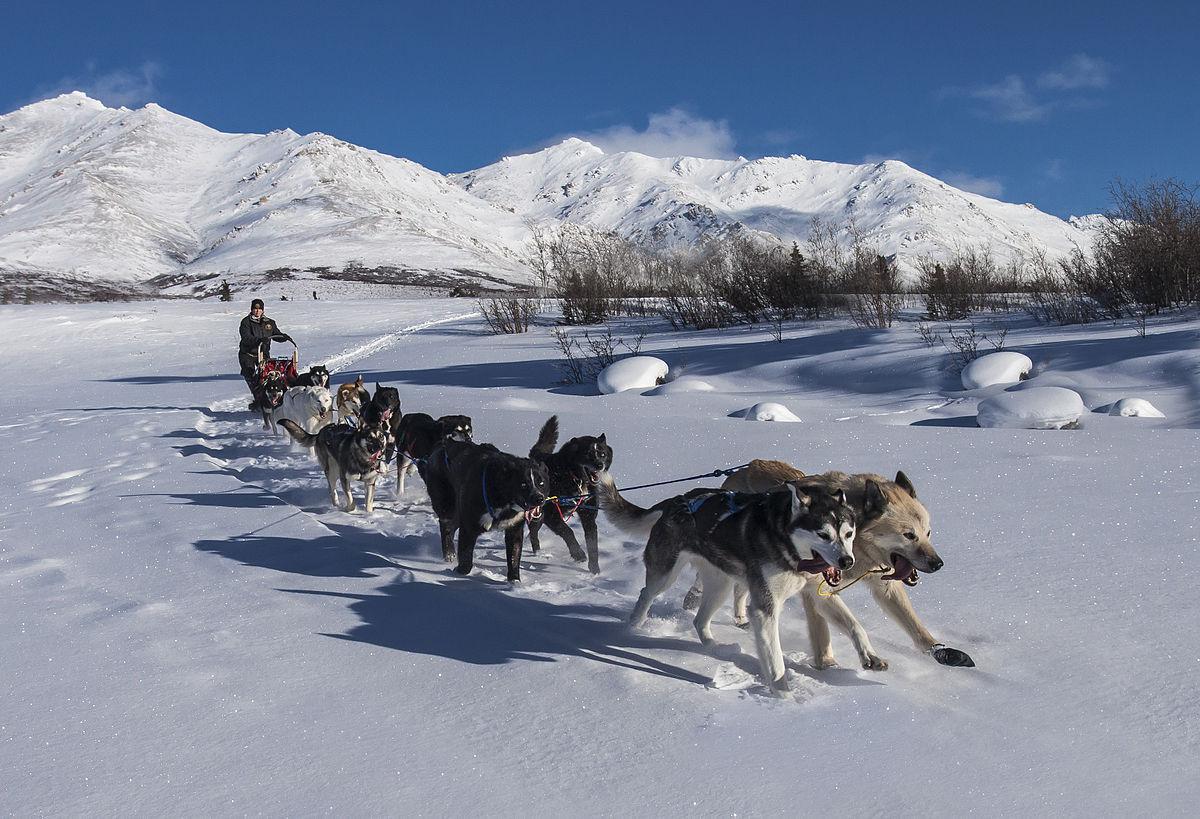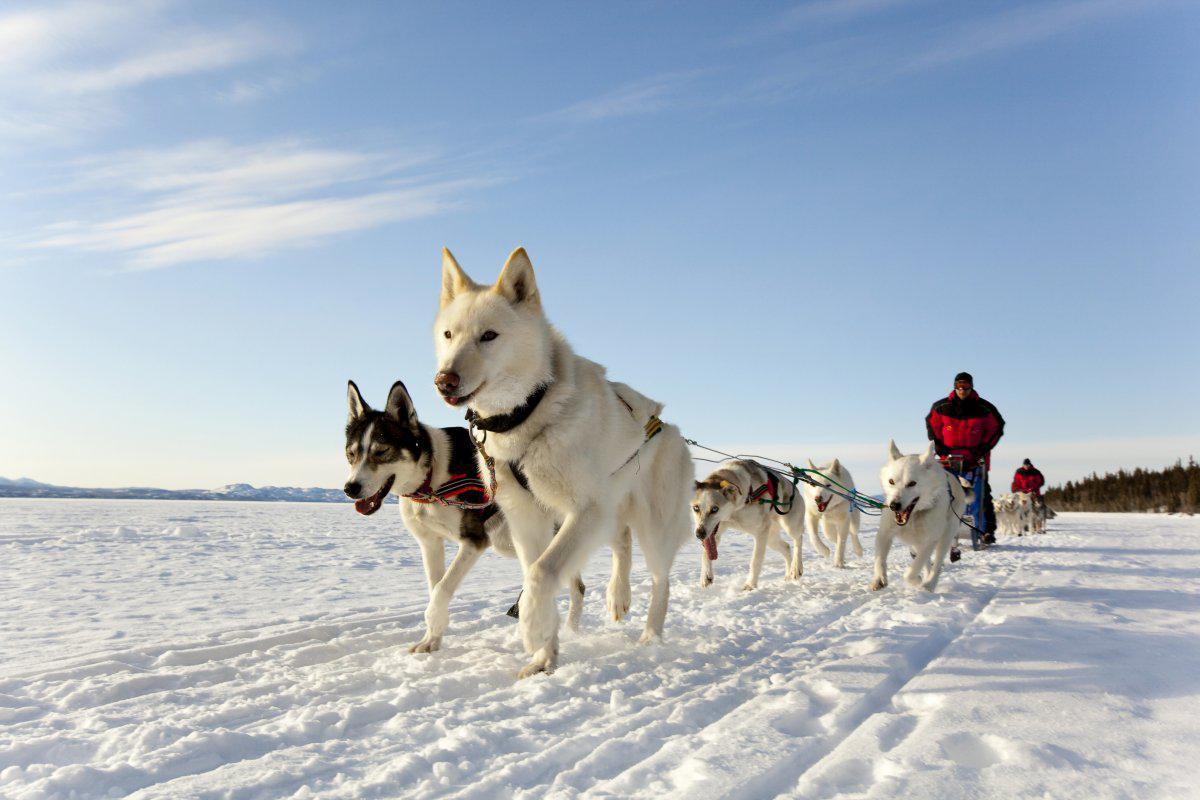The first image is the image on the left, the second image is the image on the right. Examine the images to the left and right. Is the description "None of the dogs are wearing gloves." accurate? Answer yes or no. No. 